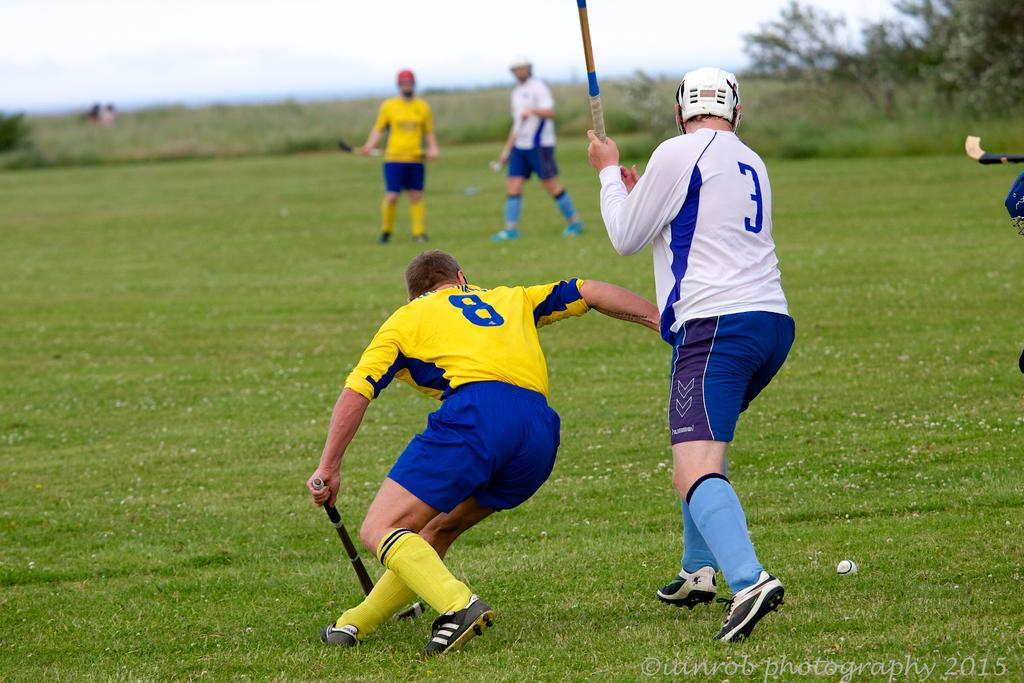<image>
Offer a succinct explanation of the picture presented. Player number 8 in yellow and player number 3 in white playing a game of field hockey. 